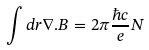Convert formula to latex. <formula><loc_0><loc_0><loc_500><loc_500>\int d r { \nabla } . { B } = 2 \pi \frac { \hbar { c } } { e } N</formula> 